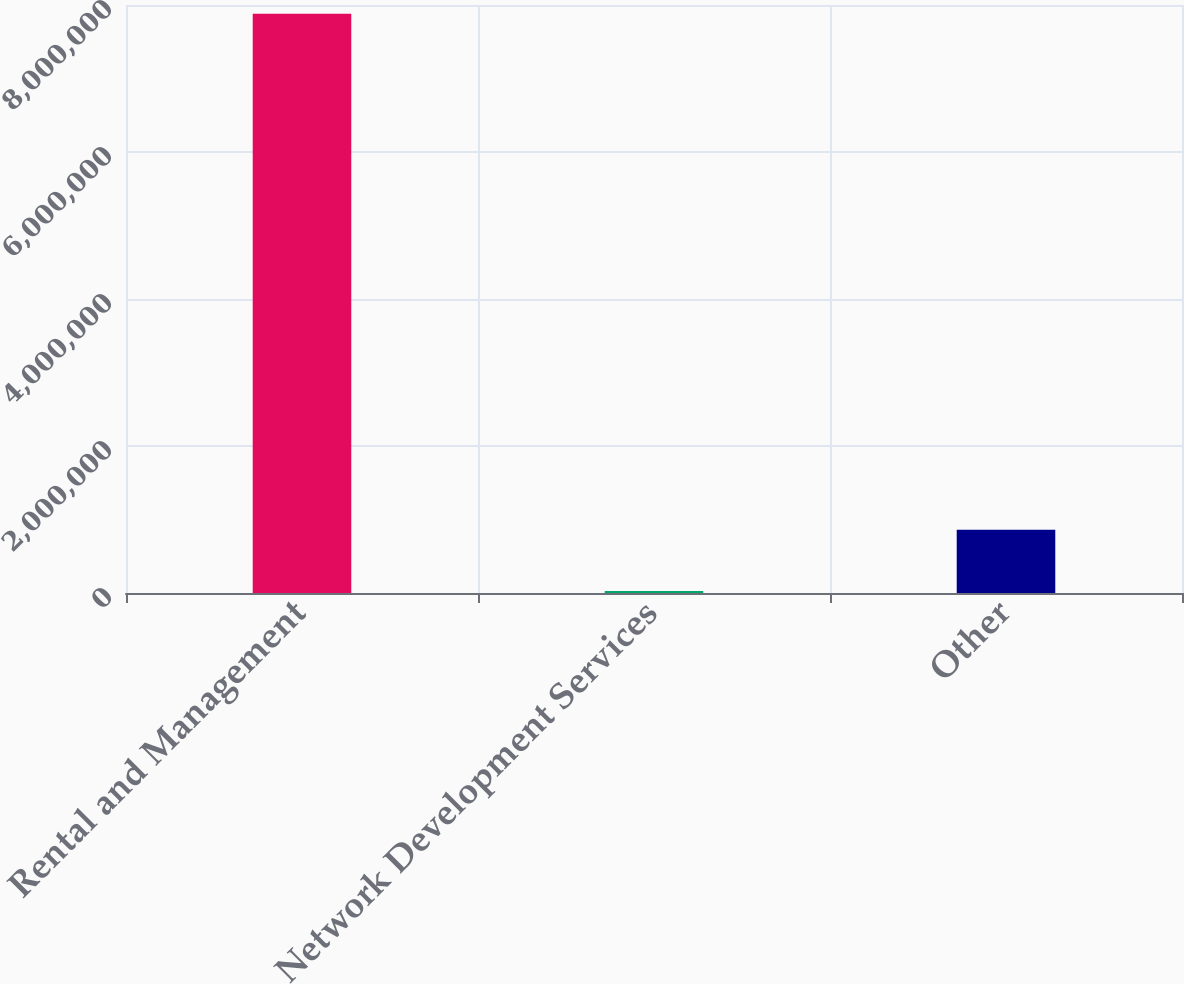Convert chart. <chart><loc_0><loc_0><loc_500><loc_500><bar_chart><fcel>Rental and Management<fcel>Network Development Services<fcel>Other<nl><fcel>7.88093e+06<fcel>26716<fcel>860576<nl></chart> 